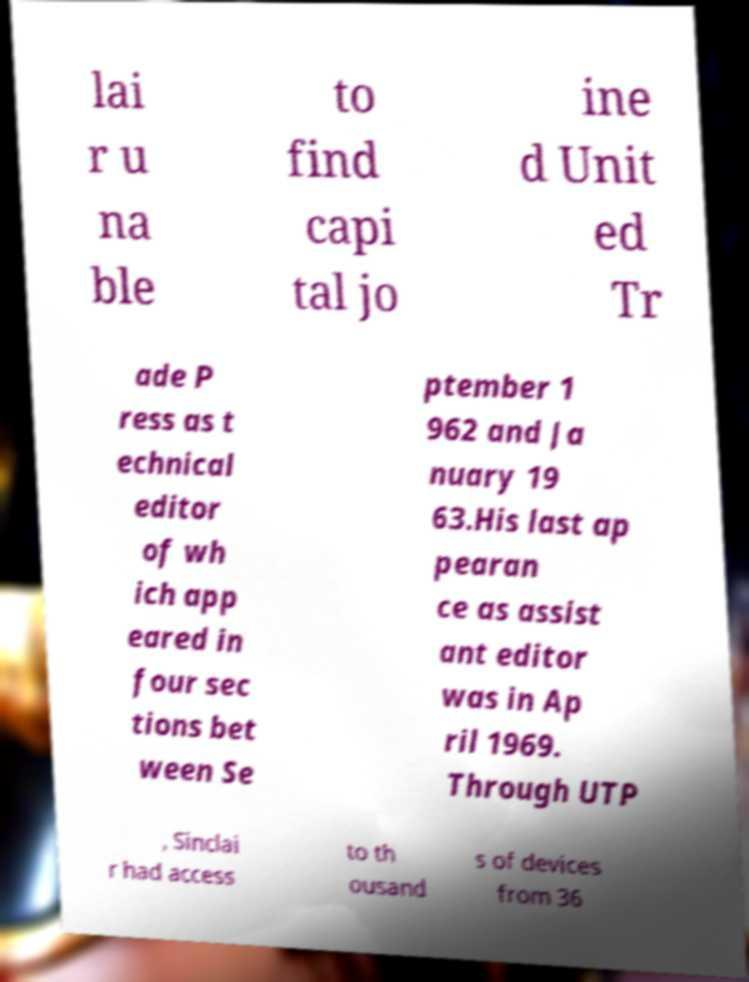I need the written content from this picture converted into text. Can you do that? lai r u na ble to find capi tal jo ine d Unit ed Tr ade P ress as t echnical editor of wh ich app eared in four sec tions bet ween Se ptember 1 962 and Ja nuary 19 63.His last ap pearan ce as assist ant editor was in Ap ril 1969. Through UTP , Sinclai r had access to th ousand s of devices from 36 